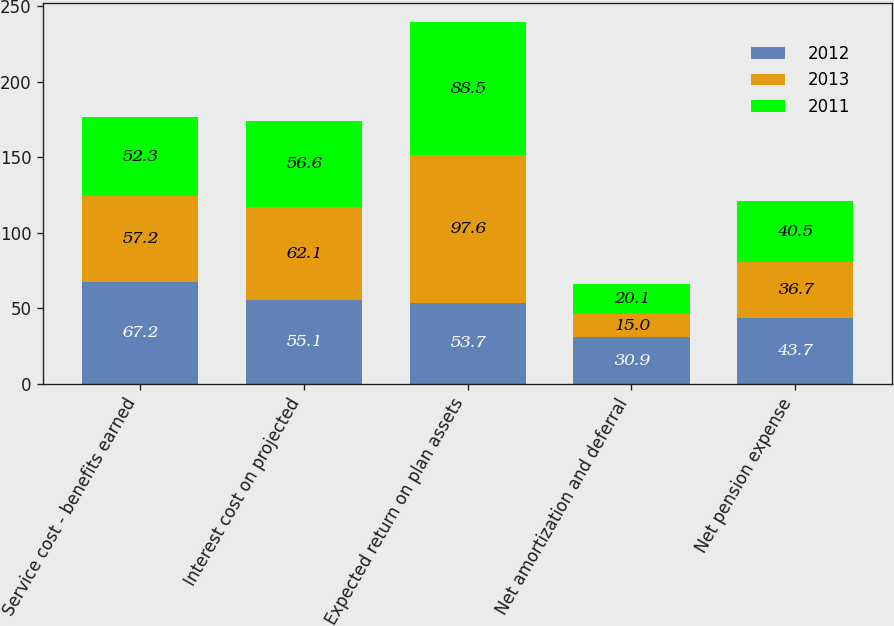Convert chart. <chart><loc_0><loc_0><loc_500><loc_500><stacked_bar_chart><ecel><fcel>Service cost - benefits earned<fcel>Interest cost on projected<fcel>Expected return on plan assets<fcel>Net amortization and deferral<fcel>Net pension expense<nl><fcel>2012<fcel>67.2<fcel>55.1<fcel>53.7<fcel>30.9<fcel>43.7<nl><fcel>2013<fcel>57.2<fcel>62.1<fcel>97.6<fcel>15<fcel>36.7<nl><fcel>2011<fcel>52.3<fcel>56.6<fcel>88.5<fcel>20.1<fcel>40.5<nl></chart> 